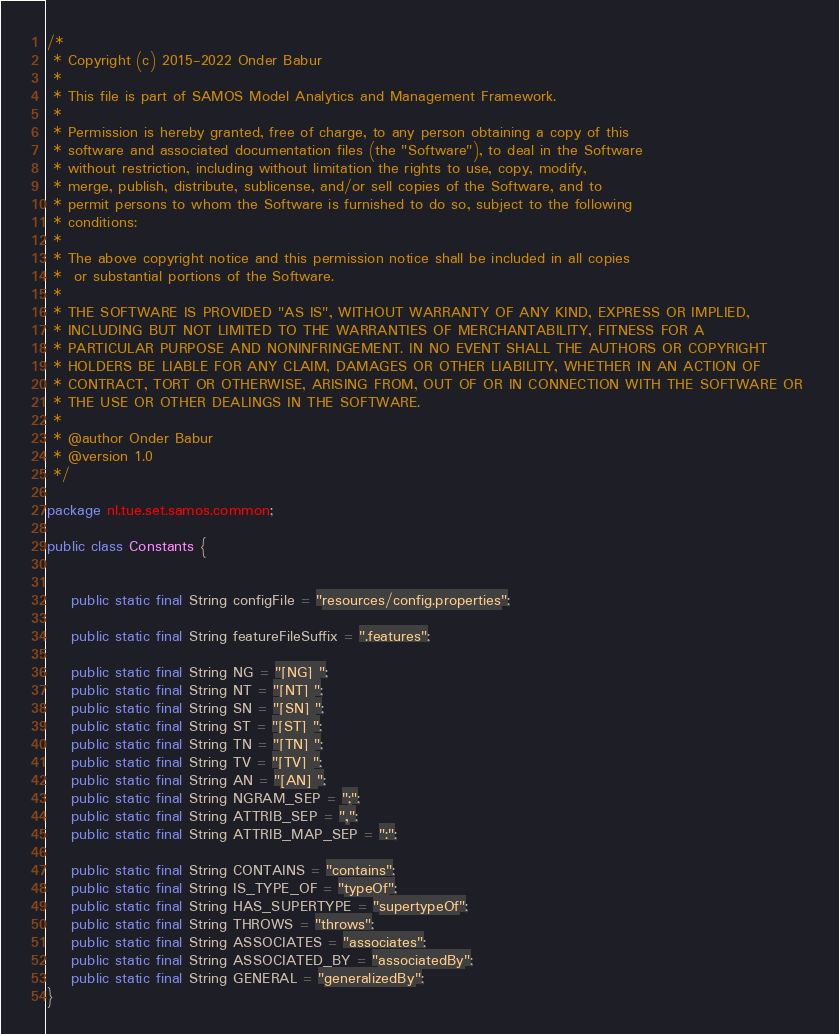<code> <loc_0><loc_0><loc_500><loc_500><_Java_>/*
 * Copyright (c) 2015-2022 Onder Babur
 * 
 * This file is part of SAMOS Model Analytics and Management Framework.
 * 
 * Permission is hereby granted, free of charge, to any person obtaining a copy of this 
 * software and associated documentation files (the "Software"), to deal in the Software 
 * without restriction, including without limitation the rights to use, copy, modify, 
 * merge, publish, distribute, sublicense, and/or sell copies of the Software, and to 
 * permit persons to whom the Software is furnished to do so, subject to the following 
 * conditions:
 * 
 * The above copyright notice and this permission notice shall be included in all copies
 *  or substantial portions of the Software.
 * 
 * THE SOFTWARE IS PROVIDED "AS IS", WITHOUT WARRANTY OF ANY KIND, EXPRESS OR IMPLIED, 
 * INCLUDING BUT NOT LIMITED TO THE WARRANTIES OF MERCHANTABILITY, FITNESS FOR A 
 * PARTICULAR PURPOSE AND NONINFRINGEMENT. IN NO EVENT SHALL THE AUTHORS OR COPYRIGHT 
 * HOLDERS BE LIABLE FOR ANY CLAIM, DAMAGES OR OTHER LIABILITY, WHETHER IN AN ACTION OF 
 * CONTRACT, TORT OR OTHERWISE, ARISING FROM, OUT OF OR IN CONNECTION WITH THE SOFTWARE OR 
 * THE USE OR OTHER DEALINGS IN THE SOFTWARE.
 * 
 * @author Onder Babur
 * @version 1.0
 */

package nl.tue.set.samos.common;

public class Constants {
	
	
	public static final String configFile = "resources/config.properties";
	
	public static final String featureFileSuffix = ".features"; 	
		
	public static final String NG = "[NG] ";
	public static final String NT = "[NT] ";
	public static final String SN = "[SN] ";
	public static final String ST = "[ST] ";
	public static final String TN = "[TN] ";
	public static final String TV = "[TV] ";
	public static final String AN = "[AN] ";
	public static final String NGRAM_SEP = ";";
	public static final String ATTRIB_SEP = ",";
	public static final String ATTRIB_MAP_SEP = ":";
	
	public static final String CONTAINS = "contains";
	public static final String IS_TYPE_OF = "typeOf";
	public static final String HAS_SUPERTYPE = "supertypeOf";
	public static final String THROWS = "throws";
	public static final String ASSOCIATES = "associates";
	public static final String ASSOCIATED_BY = "associatedBy";
	public static final String GENERAL = "generalizedBy";
}
</code> 